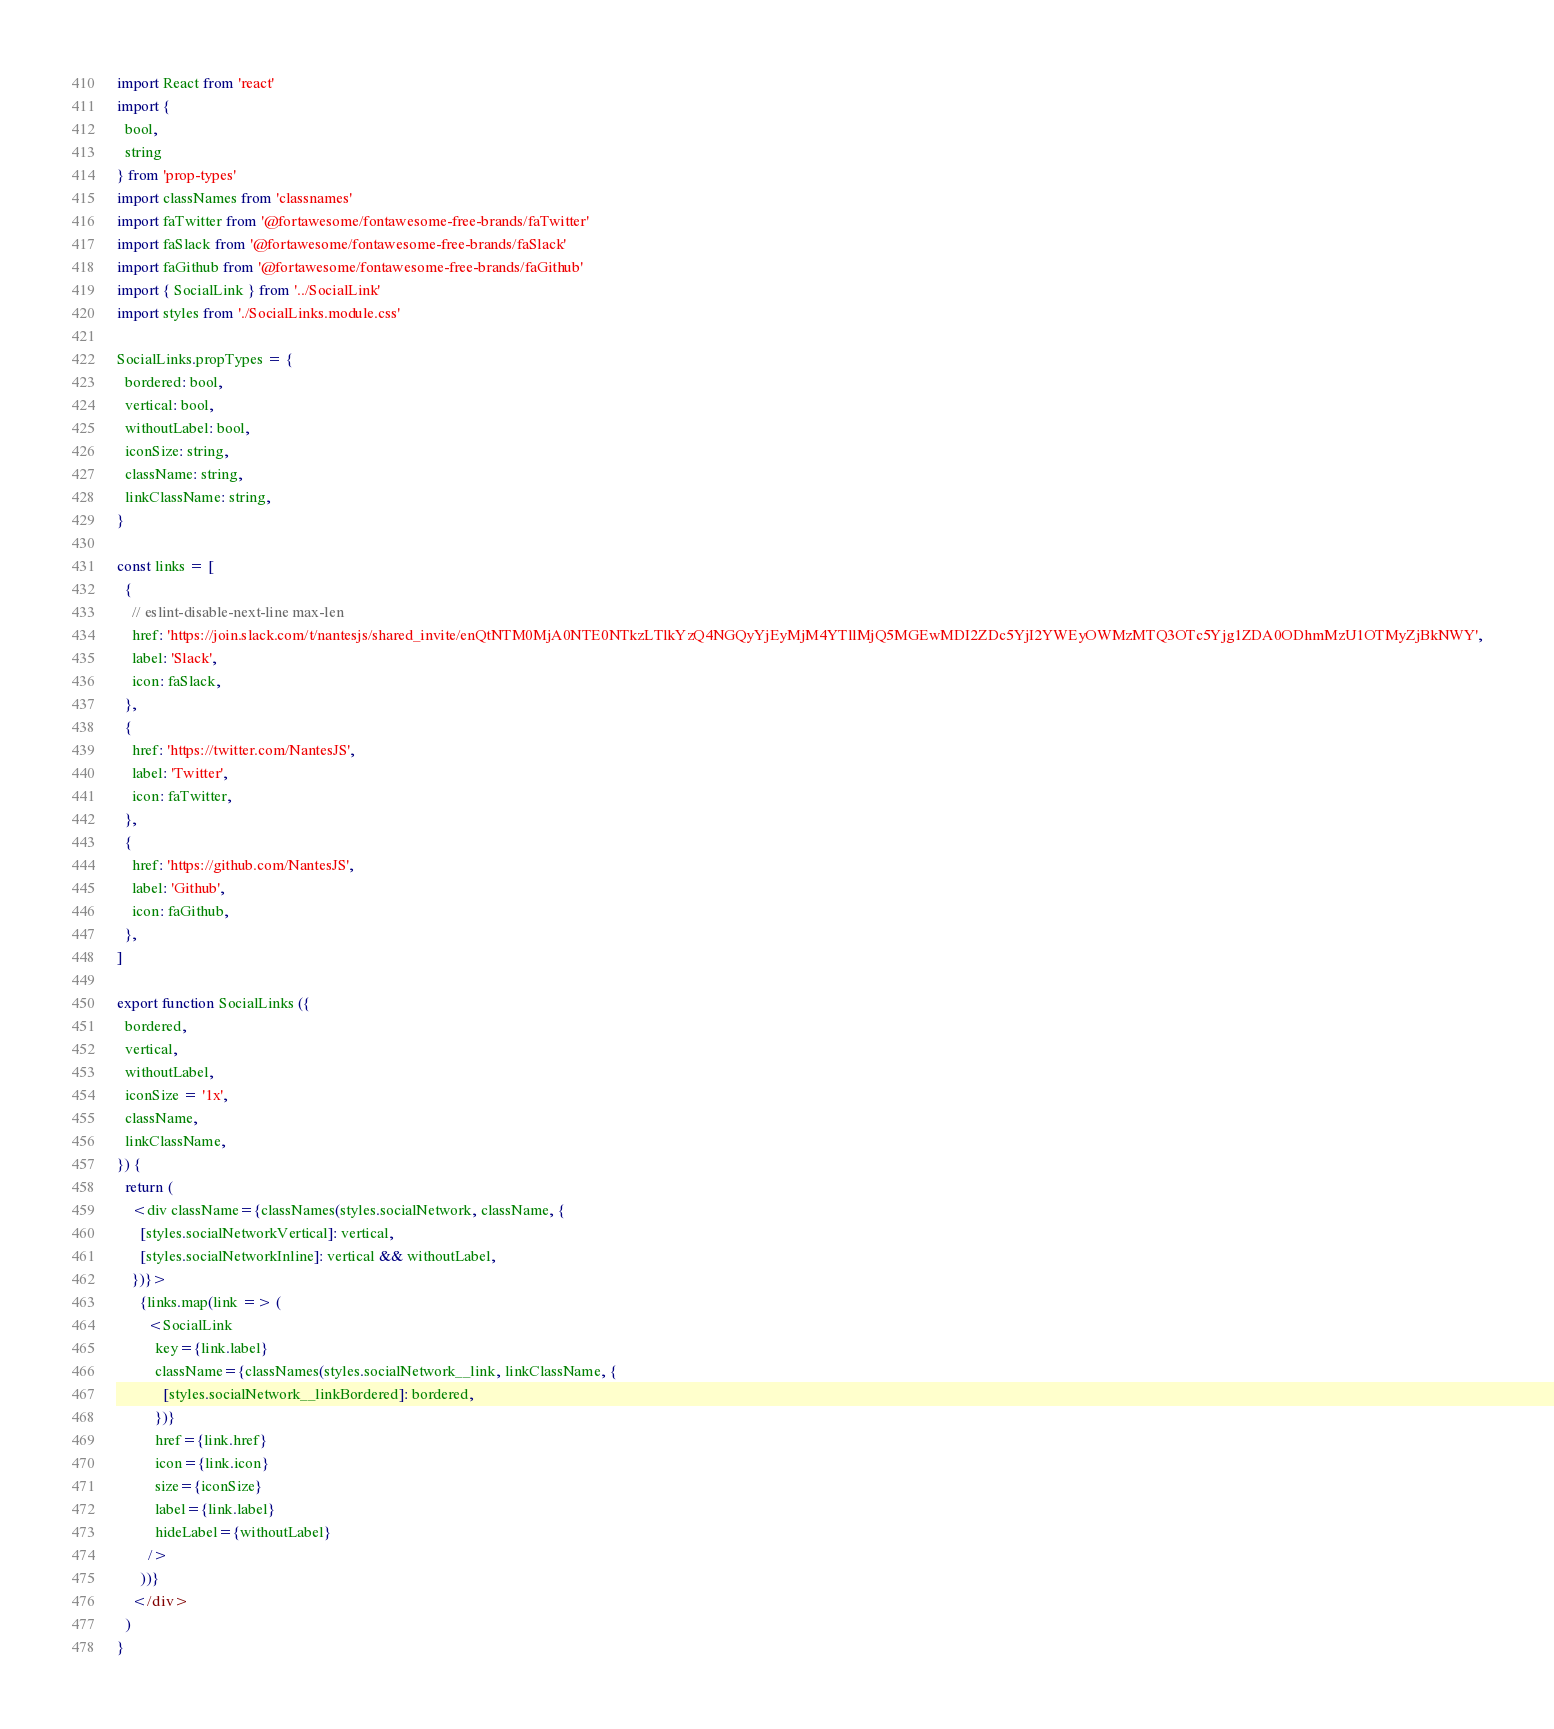Convert code to text. <code><loc_0><loc_0><loc_500><loc_500><_JavaScript_>import React from 'react'
import {
  bool,
  string
} from 'prop-types'
import classNames from 'classnames'
import faTwitter from '@fortawesome/fontawesome-free-brands/faTwitter'
import faSlack from '@fortawesome/fontawesome-free-brands/faSlack'
import faGithub from '@fortawesome/fontawesome-free-brands/faGithub'
import { SocialLink } from '../SocialLink'
import styles from './SocialLinks.module.css'

SocialLinks.propTypes = {
  bordered: bool,
  vertical: bool,
  withoutLabel: bool,
  iconSize: string,
  className: string,
  linkClassName: string,
}

const links = [
  {
    // eslint-disable-next-line max-len
    href: 'https://join.slack.com/t/nantesjs/shared_invite/enQtNTM0MjA0NTE0NTkzLTlkYzQ4NGQyYjEyMjM4YTllMjQ5MGEwMDI2ZDc5YjI2YWEyOWMzMTQ3OTc5Yjg1ZDA0ODhmMzU1OTMyZjBkNWY',
    label: 'Slack',
    icon: faSlack,
  },
  {
    href: 'https://twitter.com/NantesJS',
    label: 'Twitter',
    icon: faTwitter,
  },
  {
    href: 'https://github.com/NantesJS',
    label: 'Github',
    icon: faGithub,
  },
]

export function SocialLinks ({
  bordered,
  vertical,
  withoutLabel,
  iconSize = '1x',
  className,
  linkClassName,
}) {
  return (
    <div className={classNames(styles.socialNetwork, className, {
      [styles.socialNetworkVertical]: vertical,
      [styles.socialNetworkInline]: vertical && withoutLabel,
    })}>
      {links.map(link => (
        <SocialLink
          key={link.label}
          className={classNames(styles.socialNetwork__link, linkClassName, {
            [styles.socialNetwork__linkBordered]: bordered,
          })}
          href={link.href}
          icon={link.icon}
          size={iconSize}
          label={link.label}
          hideLabel={withoutLabel}
        />
      ))}
    </div>
  )
}
</code> 